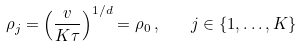<formula> <loc_0><loc_0><loc_500><loc_500>\rho _ { j } = \left ( \frac { v } { K \tau } \right ) ^ { 1 / d } = \rho _ { 0 } \, , \quad j \in \{ 1 , \dots , K \}</formula> 